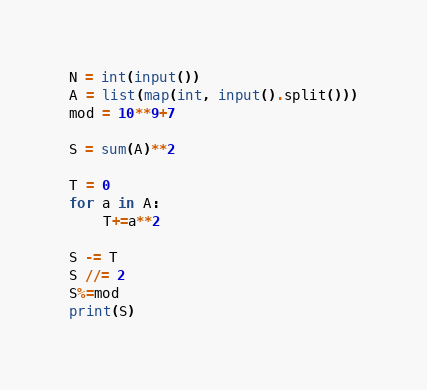Convert code to text. <code><loc_0><loc_0><loc_500><loc_500><_Python_>N = int(input())
A = list(map(int, input().split()))
mod = 10**9+7

S = sum(A)**2

T = 0
for a in A:
    T+=a**2

S -= T
S //= 2
S%=mod
print(S)</code> 